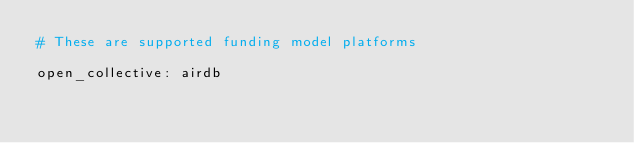<code> <loc_0><loc_0><loc_500><loc_500><_YAML_># These are supported funding model platforms

open_collective: airdb
</code> 